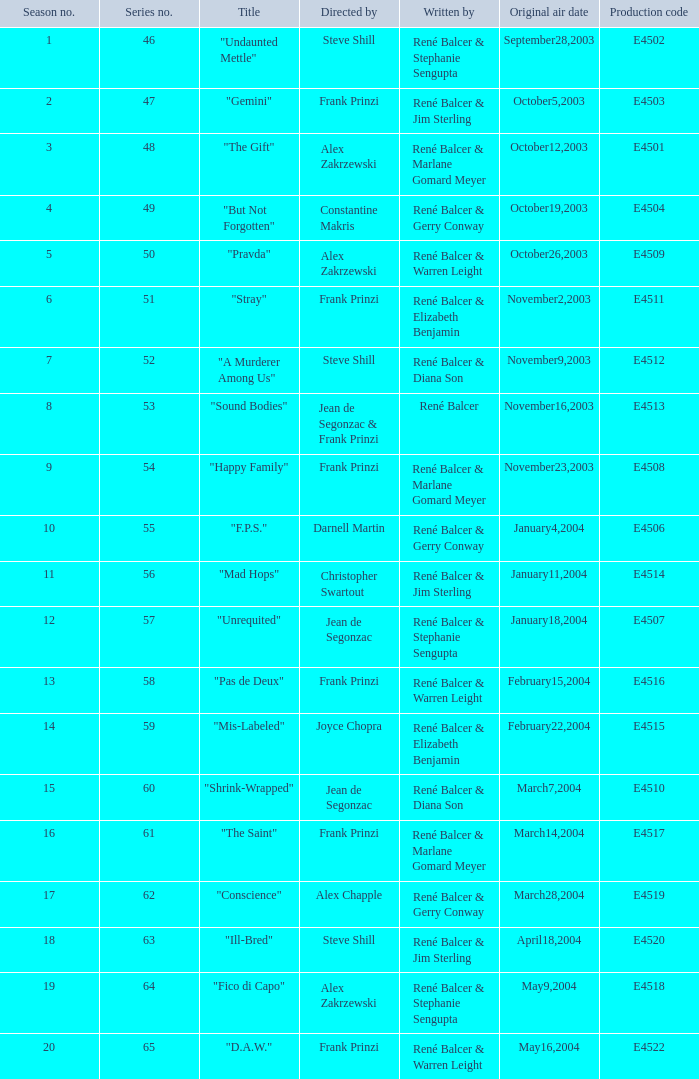What is the number of the episode titled "stray" within the season? 6.0. 